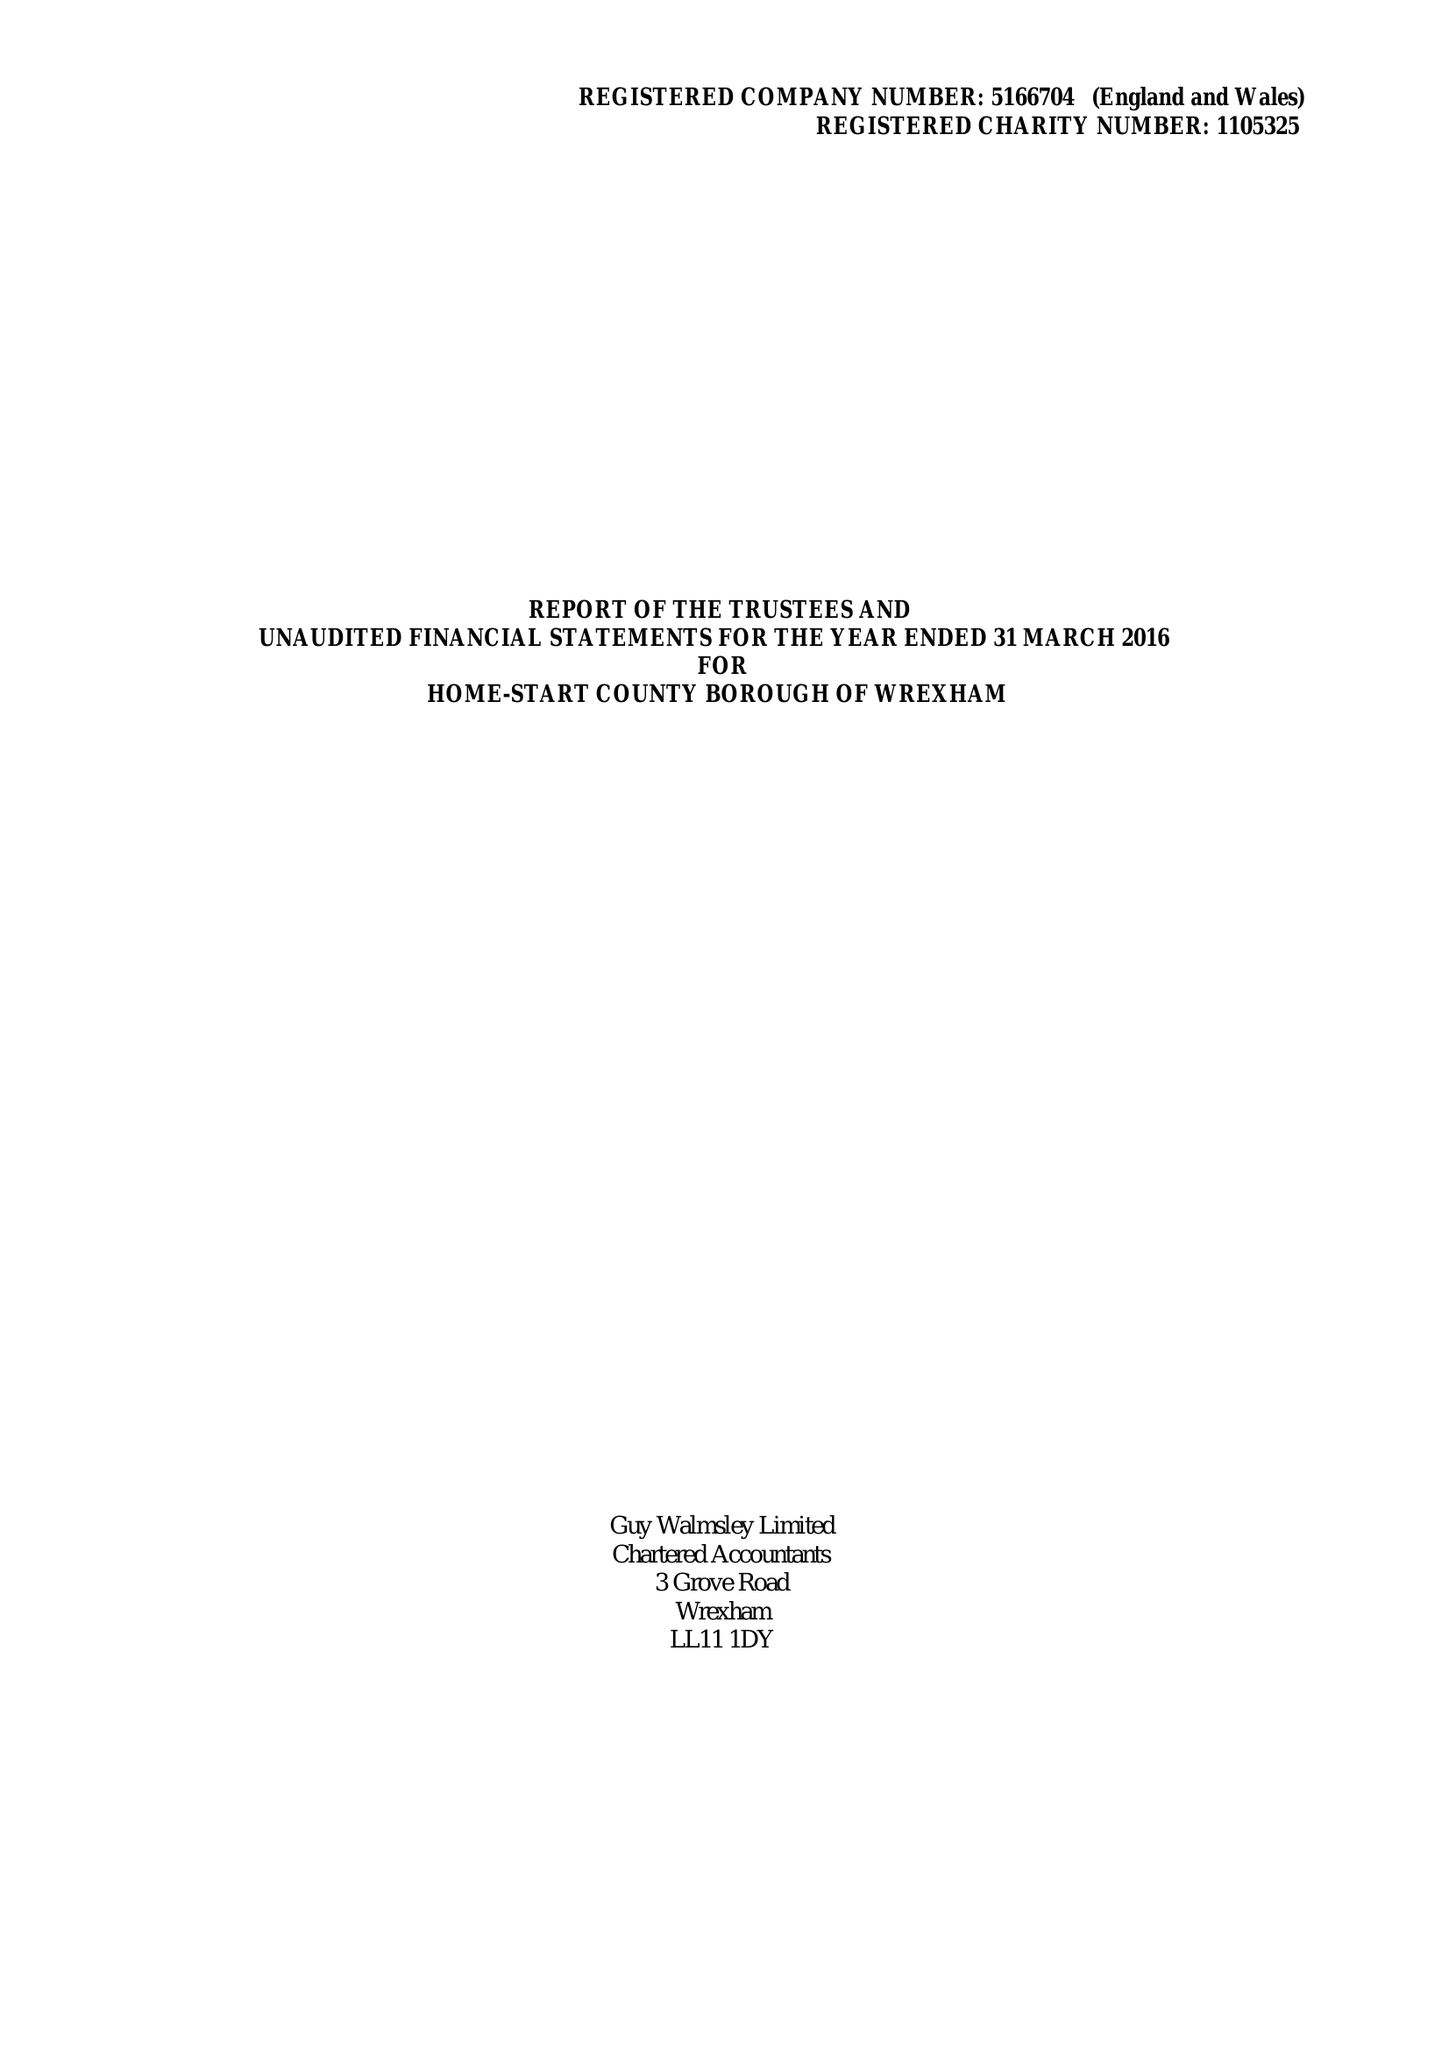What is the value for the income_annually_in_british_pounds?
Answer the question using a single word or phrase. 156261.00 